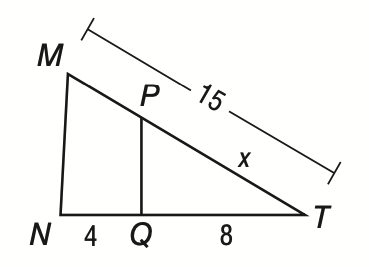Question: If M N \parallel P Q, use a proportion to find the value of x.
Choices:
A. 5
B. 8
C. 10
D. 12
Answer with the letter. Answer: C 